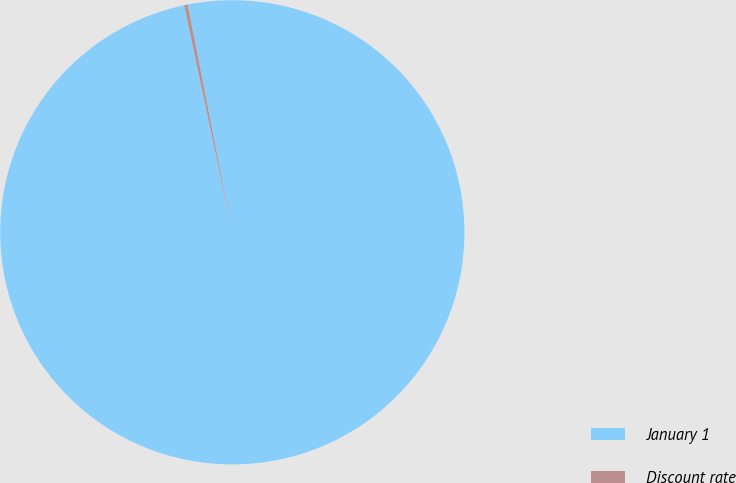Convert chart to OTSL. <chart><loc_0><loc_0><loc_500><loc_500><pie_chart><fcel>January 1<fcel>Discount rate<nl><fcel>99.75%<fcel>0.25%<nl></chart> 